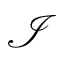Convert formula to latex. <formula><loc_0><loc_0><loc_500><loc_500>\mathcal { I }</formula> 